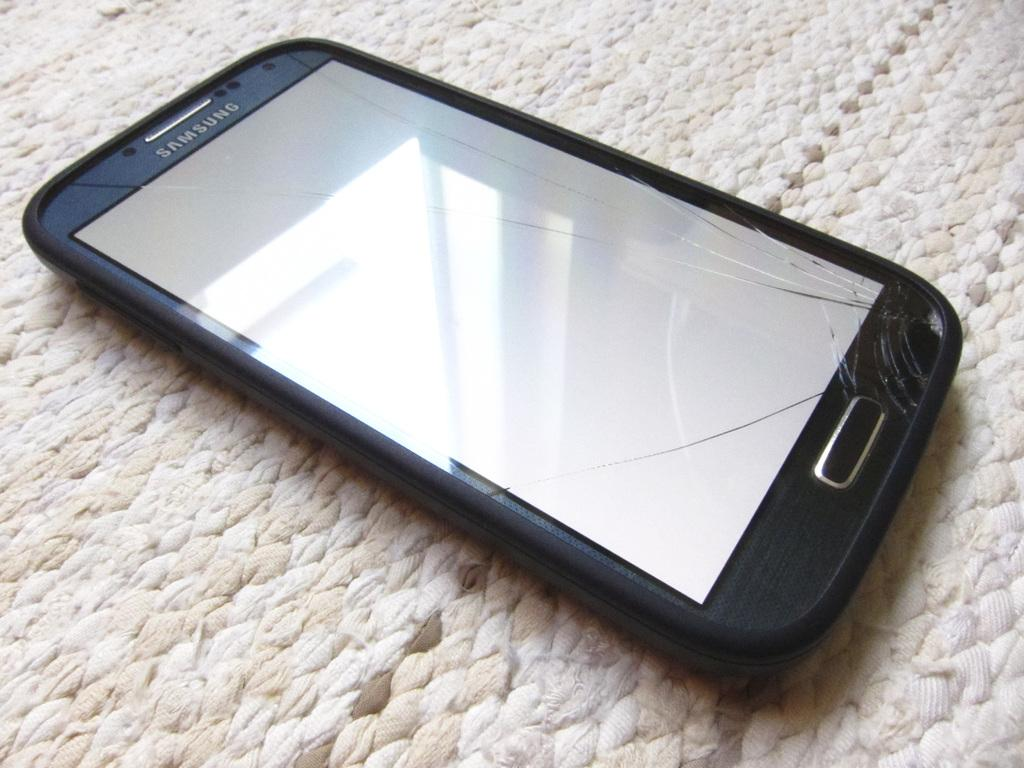<image>
Share a concise interpretation of the image provided. a broken samsung phone laying on a woven surface 